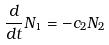<formula> <loc_0><loc_0><loc_500><loc_500>\frac { d } { d t } N _ { 1 } = - c _ { 2 } N _ { 2 }</formula> 